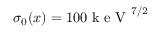Convert formula to latex. <formula><loc_0><loc_0><loc_500><loc_500>\sigma _ { 0 } ( x ) = 1 0 0 k e V ^ { 7 / 2 }</formula> 